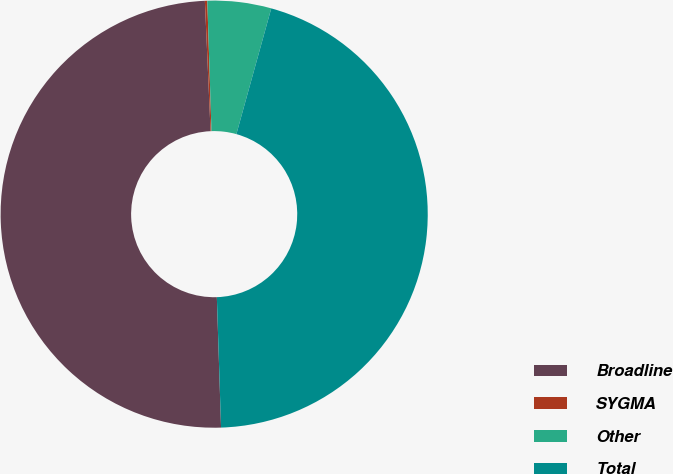<chart> <loc_0><loc_0><loc_500><loc_500><pie_chart><fcel>Broadline<fcel>SYGMA<fcel>Other<fcel>Total<nl><fcel>49.82%<fcel>0.18%<fcel>4.82%<fcel>45.18%<nl></chart> 